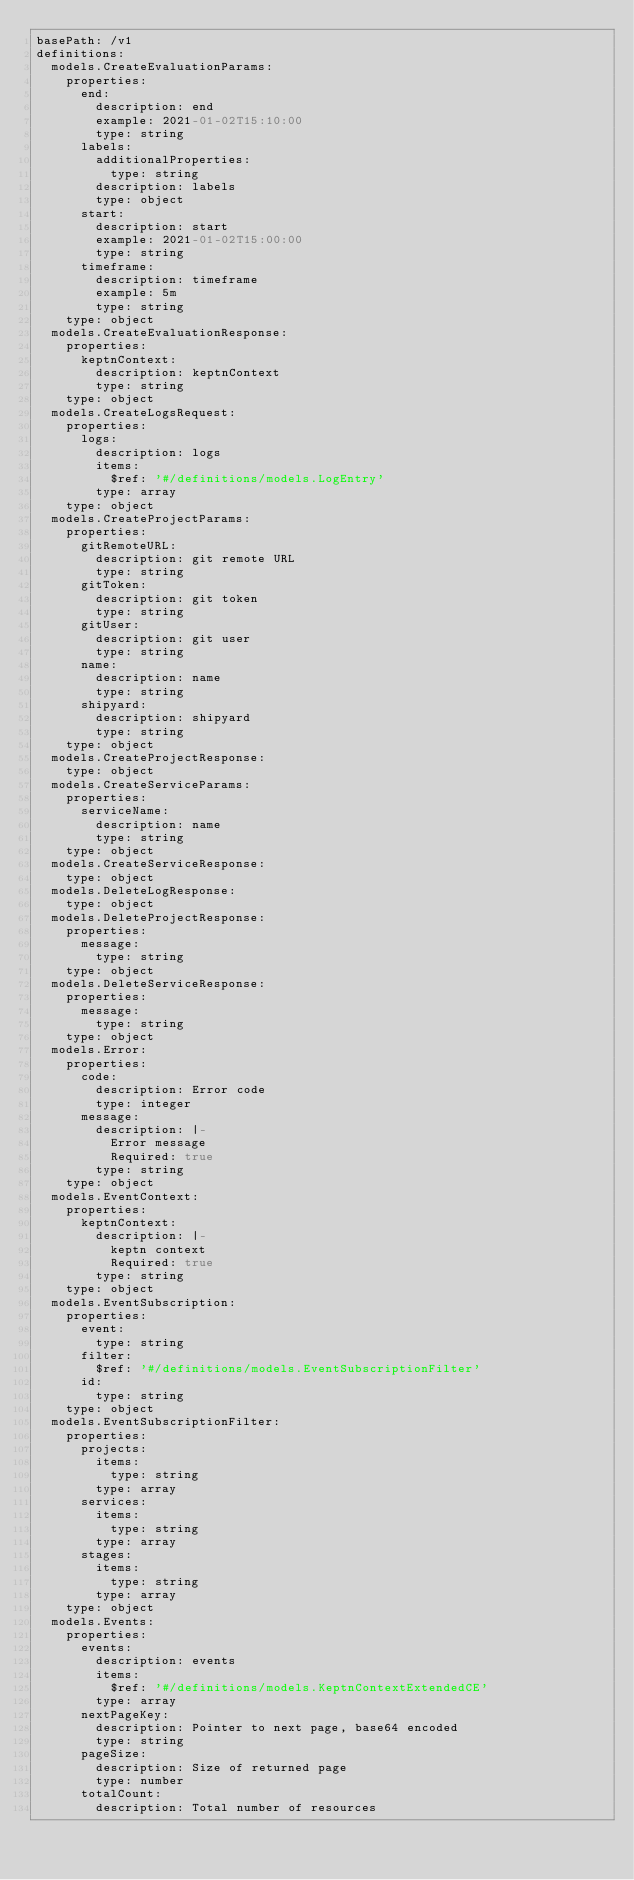<code> <loc_0><loc_0><loc_500><loc_500><_YAML_>basePath: /v1
definitions:
  models.CreateEvaluationParams:
    properties:
      end:
        description: end
        example: 2021-01-02T15:10:00
        type: string
      labels:
        additionalProperties:
          type: string
        description: labels
        type: object
      start:
        description: start
        example: 2021-01-02T15:00:00
        type: string
      timeframe:
        description: timeframe
        example: 5m
        type: string
    type: object
  models.CreateEvaluationResponse:
    properties:
      keptnContext:
        description: keptnContext
        type: string
    type: object
  models.CreateLogsRequest:
    properties:
      logs:
        description: logs
        items:
          $ref: '#/definitions/models.LogEntry'
        type: array
    type: object
  models.CreateProjectParams:
    properties:
      gitRemoteURL:
        description: git remote URL
        type: string
      gitToken:
        description: git token
        type: string
      gitUser:
        description: git user
        type: string
      name:
        description: name
        type: string
      shipyard:
        description: shipyard
        type: string
    type: object
  models.CreateProjectResponse:
    type: object
  models.CreateServiceParams:
    properties:
      serviceName:
        description: name
        type: string
    type: object
  models.CreateServiceResponse:
    type: object
  models.DeleteLogResponse:
    type: object
  models.DeleteProjectResponse:
    properties:
      message:
        type: string
    type: object
  models.DeleteServiceResponse:
    properties:
      message:
        type: string
    type: object
  models.Error:
    properties:
      code:
        description: Error code
        type: integer
      message:
        description: |-
          Error message
          Required: true
        type: string
    type: object
  models.EventContext:
    properties:
      keptnContext:
        description: |-
          keptn context
          Required: true
        type: string
    type: object
  models.EventSubscription:
    properties:
      event:
        type: string
      filter:
        $ref: '#/definitions/models.EventSubscriptionFilter'
      id:
        type: string
    type: object
  models.EventSubscriptionFilter:
    properties:
      projects:
        items:
          type: string
        type: array
      services:
        items:
          type: string
        type: array
      stages:
        items:
          type: string
        type: array
    type: object
  models.Events:
    properties:
      events:
        description: events
        items:
          $ref: '#/definitions/models.KeptnContextExtendedCE'
        type: array
      nextPageKey:
        description: Pointer to next page, base64 encoded
        type: string
      pageSize:
        description: Size of returned page
        type: number
      totalCount:
        description: Total number of resources</code> 